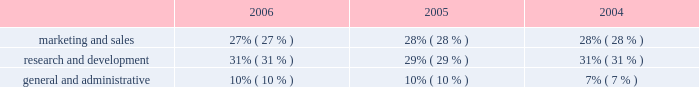Operating expenses as a percentage of total revenue .
Operating expense summary 2006 compared to 2005 overall operating expenses increased $ 122.5 million in 2006 , as compared to 2005 , primarily due to : 2022 an increase of $ 58.4 million in stock-based compensation expense due to our adoption of sfas no .
123r ; and 2022 an increase of $ 49.2 million in salary , benefits and other employee-related costs , primarily due to an increased number of employees and increases in bonus and commission costs , in part due to our acquisition of verisity ltd. , or verisity , in the second quarter of 2005 .
2005 compared to 2004 operating expenses increased $ 97.4 million in 2005 , as compared to 2004 , primarily due to : 2022 an increase of $ 63.3 million in employee salary and benefit costs , primarily due to our acquisition of verisity and increased bonus and commission costs ; 2022 an increase of $ 9.9 million in stock-based compensation expense due to grants of restricted stock and the assumption of options in our acquisitions ; 2022 an increase of $ 8.6 million in losses associated with the sale of installment contract receivables ; and 2022 an increase of $ 7.1 million in costs related to the retirement of our executive chairman and former president and chief executive officer in 2005 ; partially offset by 2022 our restructuring activities , as discussed below .
Marketing and sales 2006 compared to 2005 marketing and sales expenses increased $ 39.4 million in 2006 , as compared to 2005 , primarily due to : 2022 an increase of $ 14.8 million in stock-based compensation expense due to our adoption of sfas no .
123r ; 2022 an increase of $ 18.2 million in employee salary , commissions , benefits and other employee-related costs due to increased hiring of sales and technical personnel , and higher commissions earned resulting from an increase in 2006 sales performance ; and 2022 an increase of $ 7.8 million in marketing programs and customer-focused conferences due to our new marketing initiatives and increased travel to visit our customers .
2005 compared to 2004 marketing and sales expenses increased $ 33.1 million in 2005 , as compared to 2004 , primarily due to : 2022 an increase of $ 29.4 million in employee salary , commission and benefit costs due to increased hiring of sales and technical personnel and higher employee bonuses and commissions ; and 2022 an increase of $ 1.6 million in stock-based compensation expense due to grants of restricted stock and the assumption of options in our acquisitions ; partially offset by 2022 a decrease of $ 1.9 million in marketing program costs. .
What was the change in marketing and sales expenses as a percentage of total revenue from 2005 to 2006? 
Computations: (27% - 28%)
Answer: -0.01. 